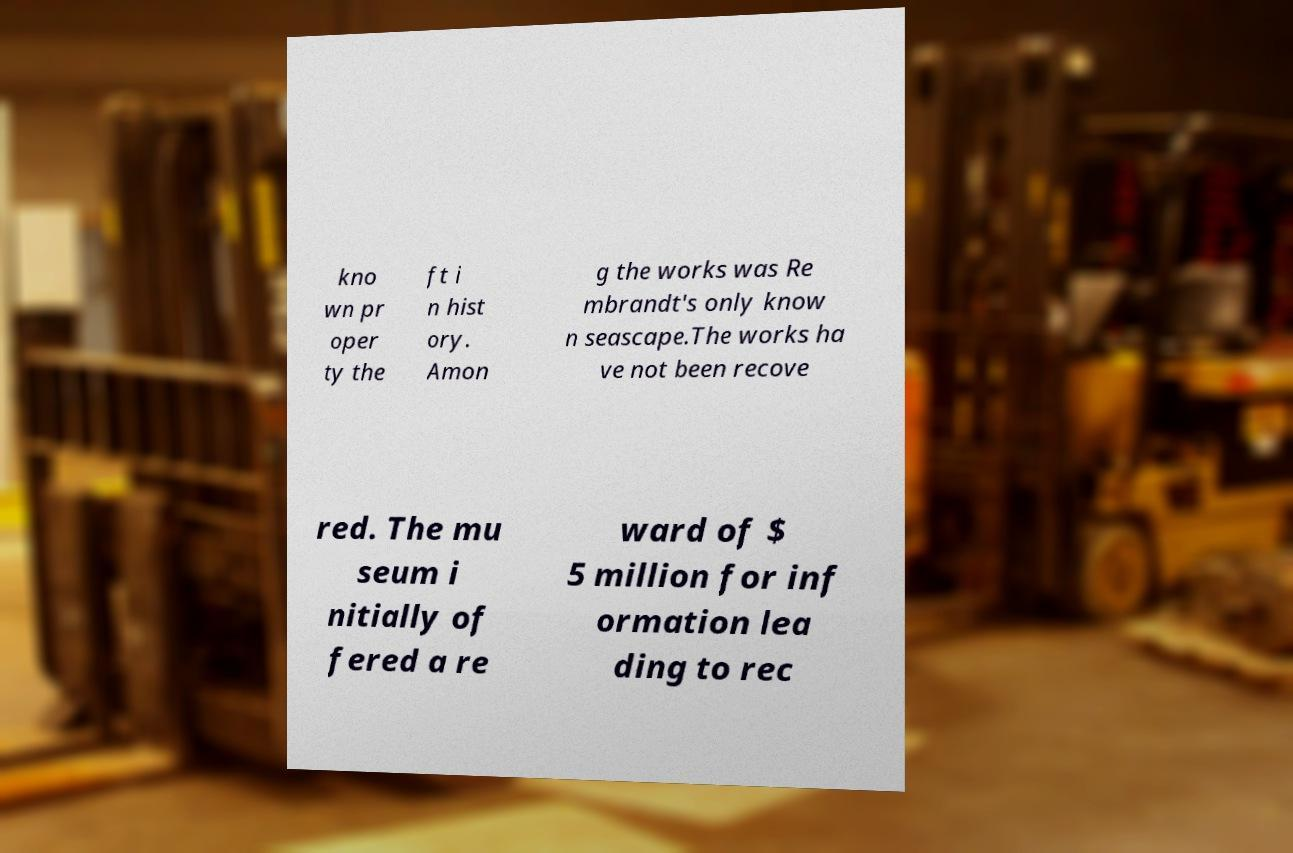Can you accurately transcribe the text from the provided image for me? kno wn pr oper ty the ft i n hist ory. Amon g the works was Re mbrandt's only know n seascape.The works ha ve not been recove red. The mu seum i nitially of fered a re ward of $ 5 million for inf ormation lea ding to rec 